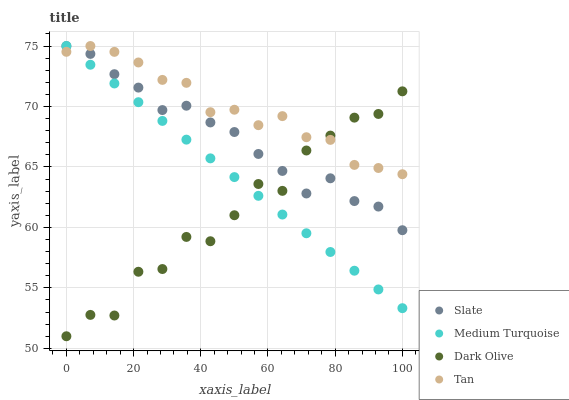Does Dark Olive have the minimum area under the curve?
Answer yes or no. Yes. Does Tan have the maximum area under the curve?
Answer yes or no. Yes. Does Tan have the minimum area under the curve?
Answer yes or no. No. Does Dark Olive have the maximum area under the curve?
Answer yes or no. No. Is Medium Turquoise the smoothest?
Answer yes or no. Yes. Is Dark Olive the roughest?
Answer yes or no. Yes. Is Tan the smoothest?
Answer yes or no. No. Is Tan the roughest?
Answer yes or no. No. Does Dark Olive have the lowest value?
Answer yes or no. Yes. Does Tan have the lowest value?
Answer yes or no. No. Does Medium Turquoise have the highest value?
Answer yes or no. Yes. Does Dark Olive have the highest value?
Answer yes or no. No. Does Medium Turquoise intersect Dark Olive?
Answer yes or no. Yes. Is Medium Turquoise less than Dark Olive?
Answer yes or no. No. Is Medium Turquoise greater than Dark Olive?
Answer yes or no. No. 